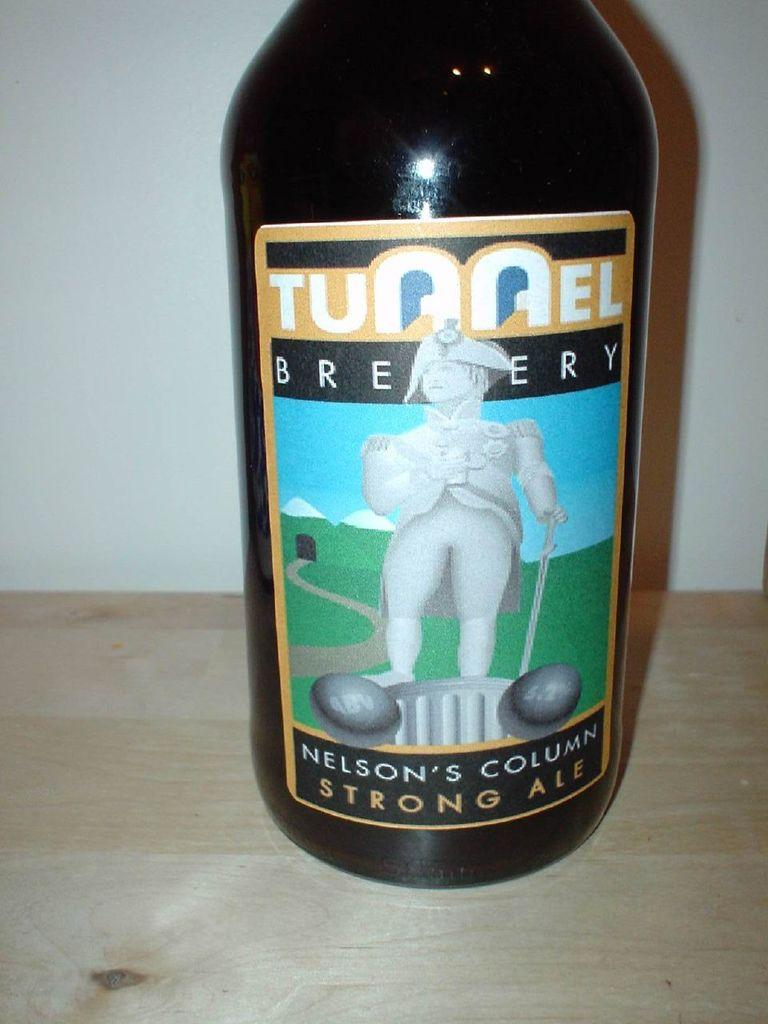<image>
Offer a succinct explanation of the picture presented. A beer bottle reads Tunnel Brewery on the label. 